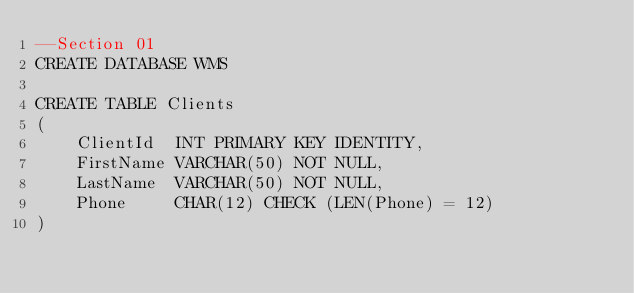<code> <loc_0><loc_0><loc_500><loc_500><_SQL_>--Section 01
CREATE DATABASE WMS

CREATE TABLE Clients
(
    ClientId  INT PRIMARY KEY IDENTITY,
    FirstName VARCHAR(50) NOT NULL,
    LastName  VARCHAR(50) NOT NULL,
    Phone     CHAR(12) CHECK (LEN(Phone) = 12)
)
</code> 